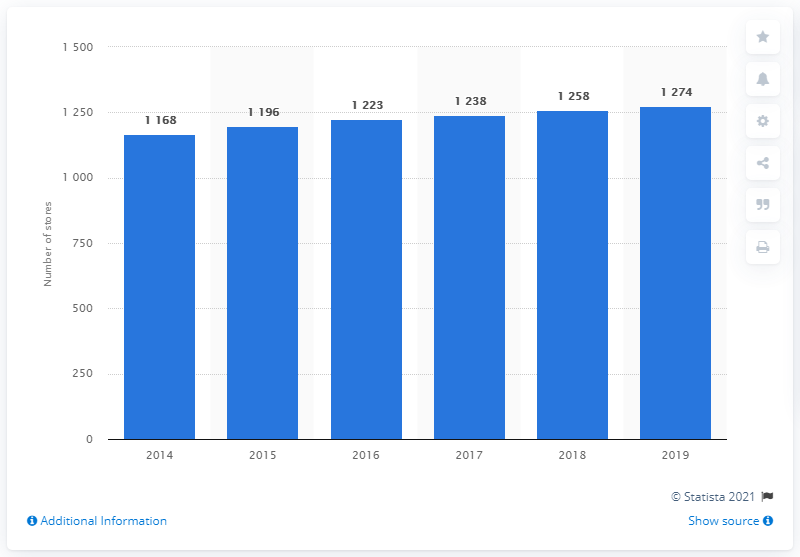Indicate a few pertinent items in this graphic. In 2018, there were 1,258 stores. The sum of the middle two values is 2461. 